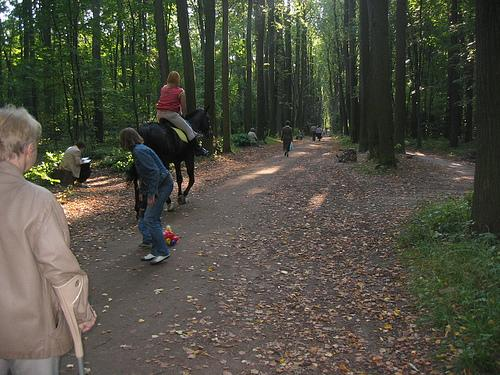What is helping someone walk? horse 